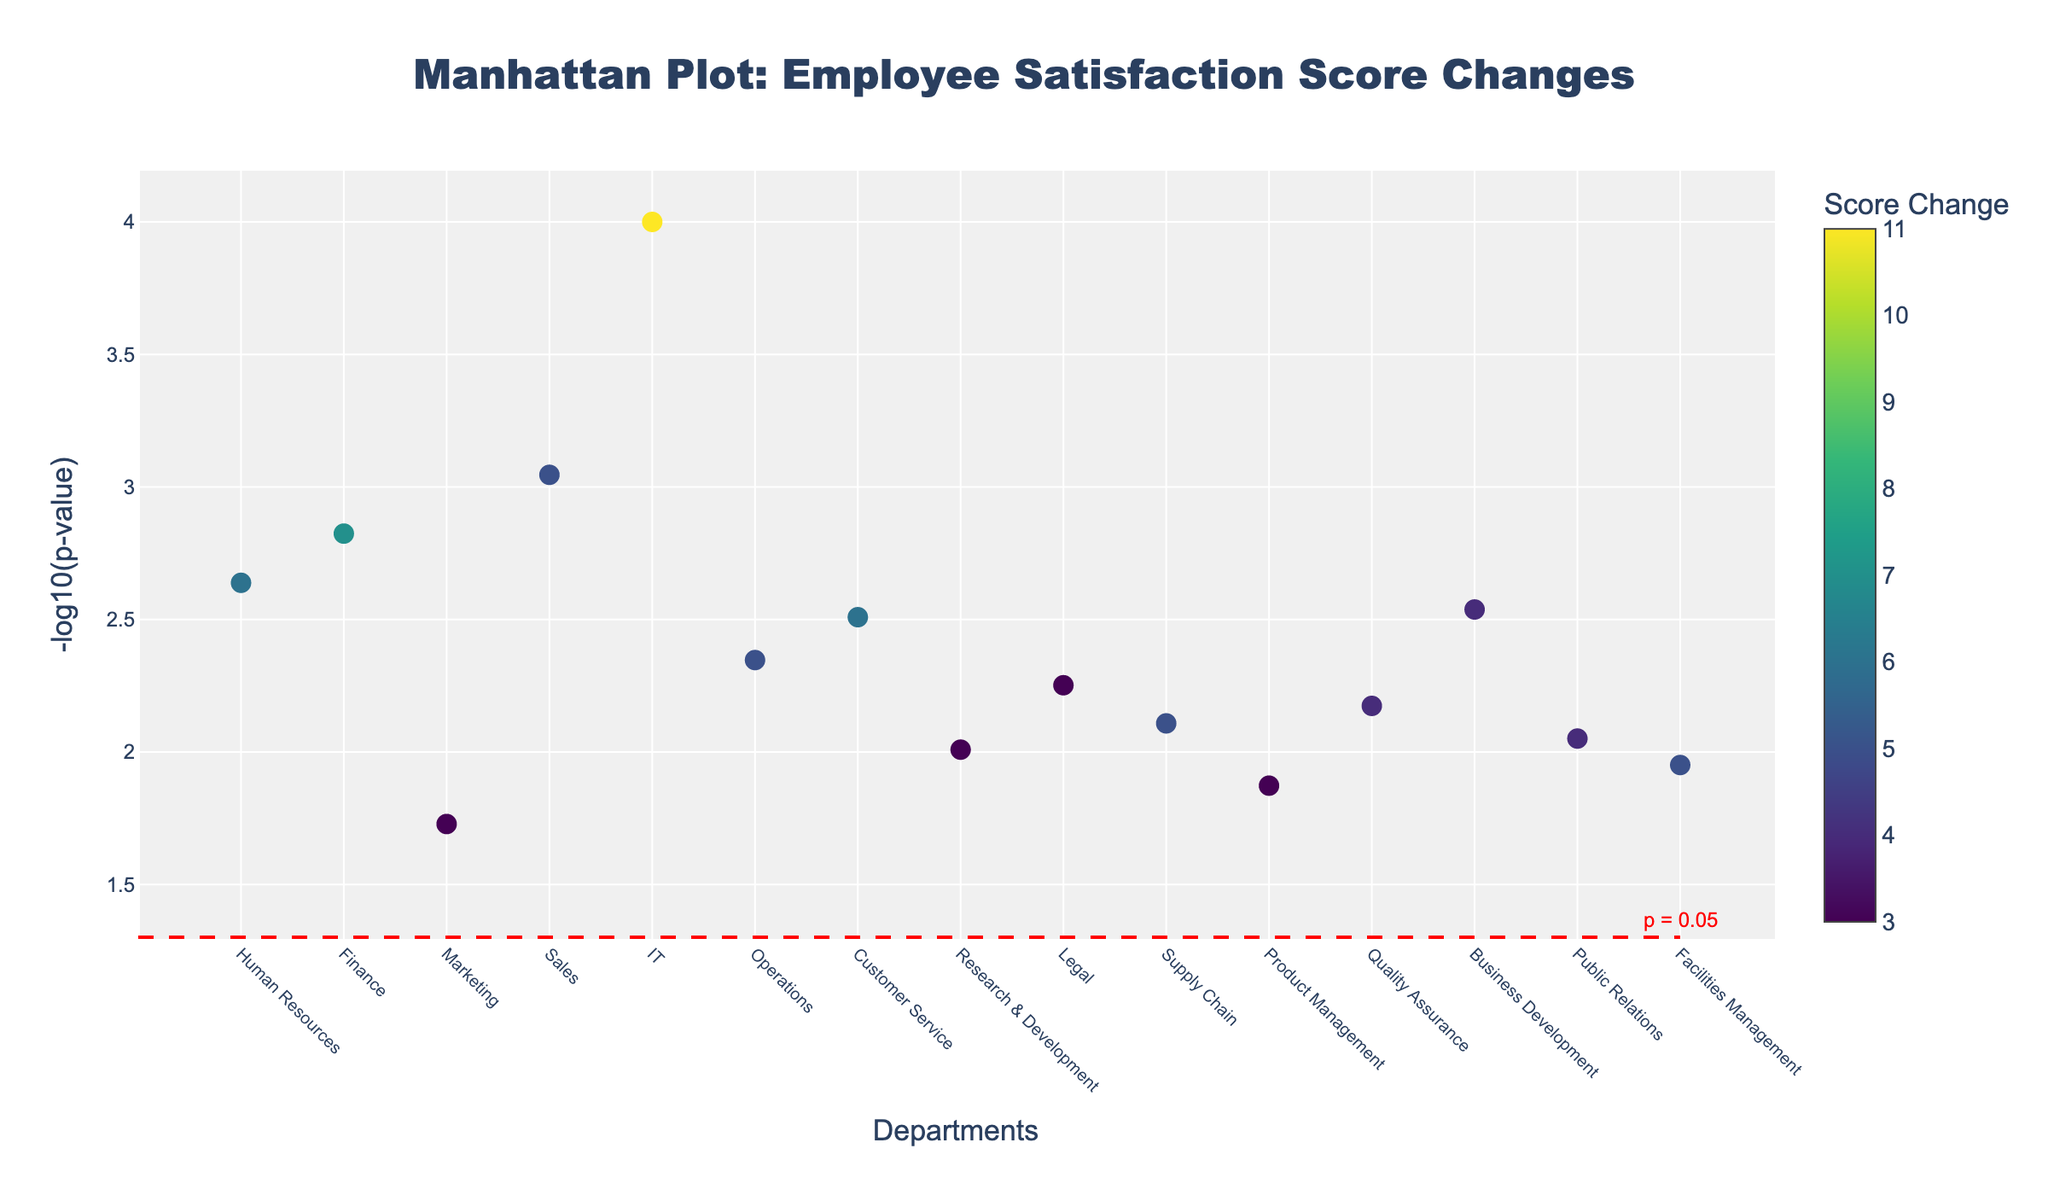What's the title of the plot? The title of the plot is displayed at the top and reads "Manhattan Plot: Employee Satisfaction Score Changes".
Answer: Manhattan Plot: Employee Satisfaction Score Changes What does the y-axis represent? The y-axis represents the negative logarithm (base 10) of the p-values. This is typically denoted as -log10(p-value).
Answer: -log10(p-value) Which department has the lowest p-value? The department with the lowest p-value will correspond to the highest point on the y-axis. By inspecting the plot, the IT department has the highest value on the y-axis (position 5).
Answer: IT How many departments have a p-value less than 0.05? The threshold line at -log10(p-value) = 1.3 (since -log10(0.05)=1.3) helps identify significant departments. By counting the points above this line, we see that there are multiple departments (11 in total) with a p-value less than 0.05.
Answer: 11 Which department had the highest increase in employee satisfaction scores? The department with the highest change is indicated by the darkest color and a higher value on the color bar labeled "Score Change". The Sales department (position 4) shows the highest increase.
Answer: Sales Which departments have a p-value between 0.01 and 0.02? To find the departments with p-values between 0.01 and 0.02, look for y-axis values between 1.7 (since -log10(0.02)~1.7) and 2. These departments correspond to the points at these y-axis values. The departments are Marketing and Public Relations.
Answer: Marketing, Public Relations Are there any departments with a satisfaction score change of zero? A zero satisfaction score change would imply a specific color on the color scale, but no such color is present for zero. All data points indicate some change in score. Hence, there are no departments with a satisfaction score change of zero.
Answer: No Which department has the smallest increase in employee satisfaction scores? The department with the smallest increase will be indicated by the lightest color on the color bar. Inspecting the plot shows that Marketing (position 3) has the smallest increase.
Answer: Marketing 